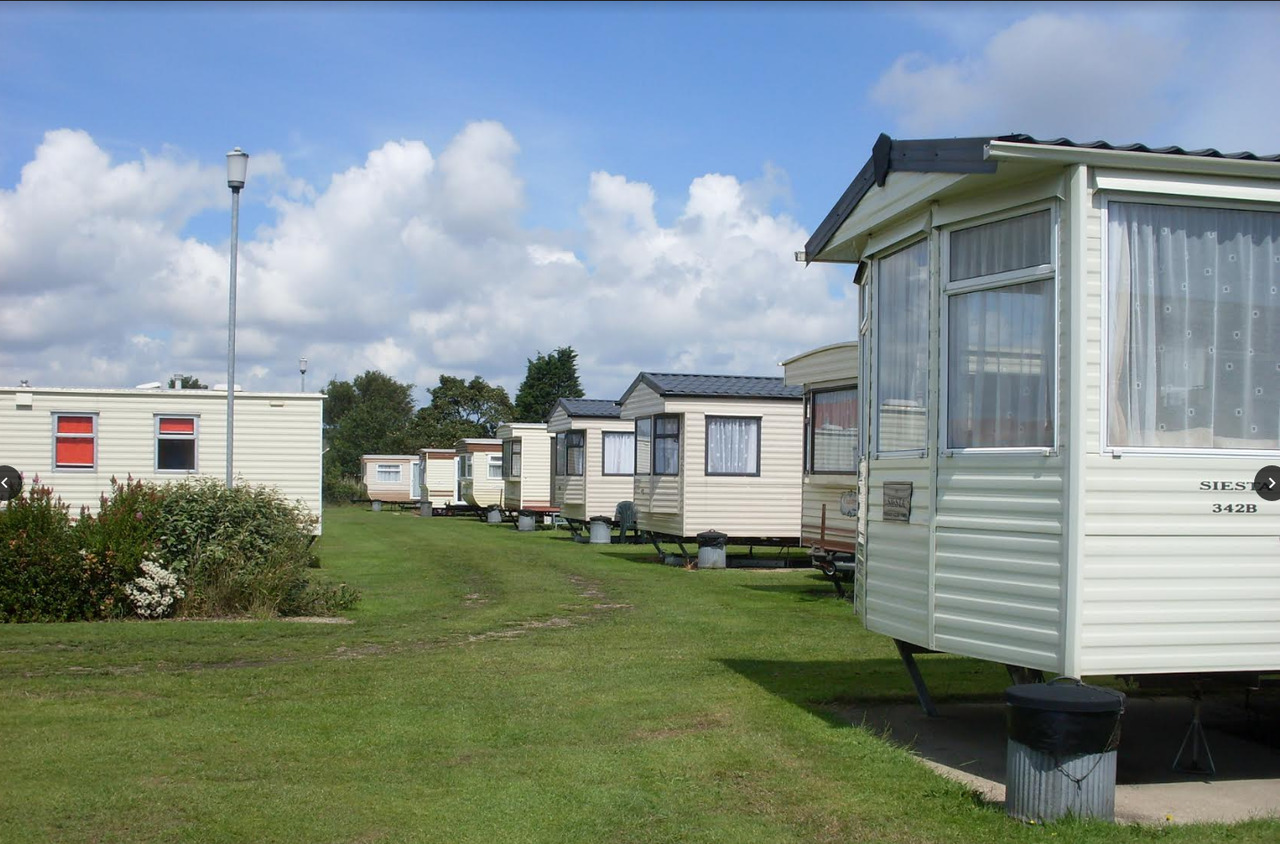Imagine a bustling summer weekend here; what kind of activities and atmosphere would you expect? On a bustling summer weekend, the caravan park would be full of vibrant activities. Children would be playing games on the grassy patches, families might be having barbecues near their caravans, and there would be people strolling leisurely, enjoying the scenic surroundings. The sound of laughter and chatter would fill the air as residents and tourists mingle. In the evening, community gatherings or events like outdoor movie nights could be held, bringing everyone together for a memorable experience. 